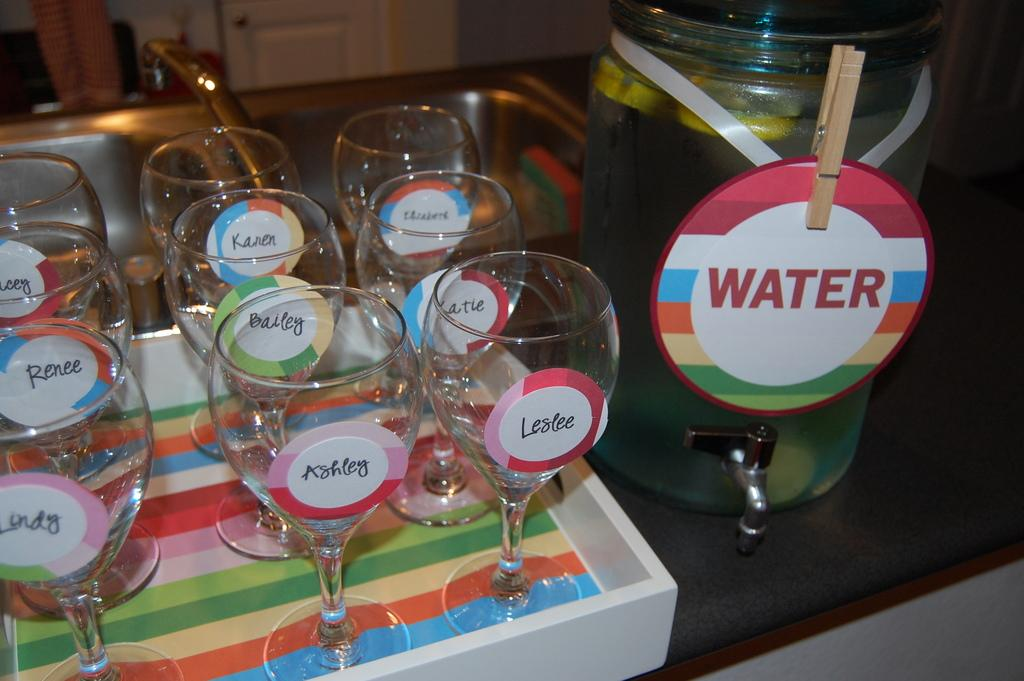What type of dishware can be seen in the image? There are glasses and bowls in the image. Where are the glasses and bowls located? The glasses and bowls are placed near a washbasin. How many cherries can be seen floating on the waves in the image? There are no cherries or waves present in the image. 